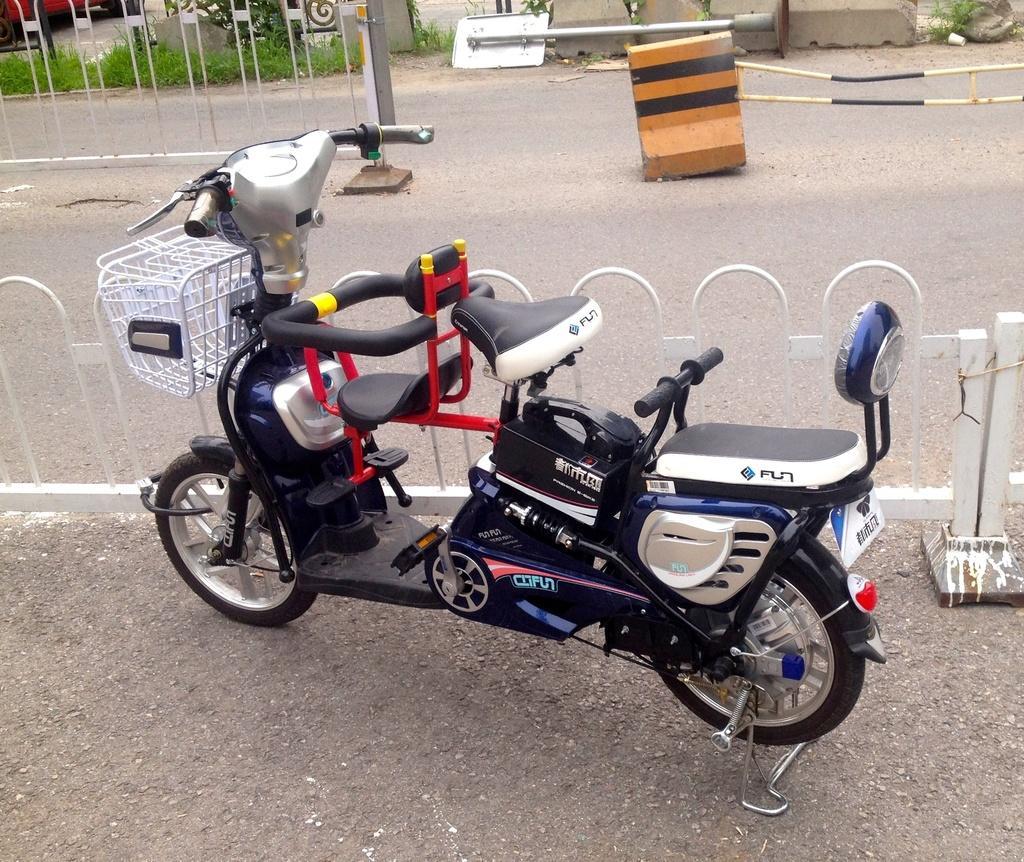Can you describe this image briefly? In the image there is a vehicle parked on the road and behind that there is a fencing, behind that fencing there is an empty road and in the background there is a board fell down on the ground. 